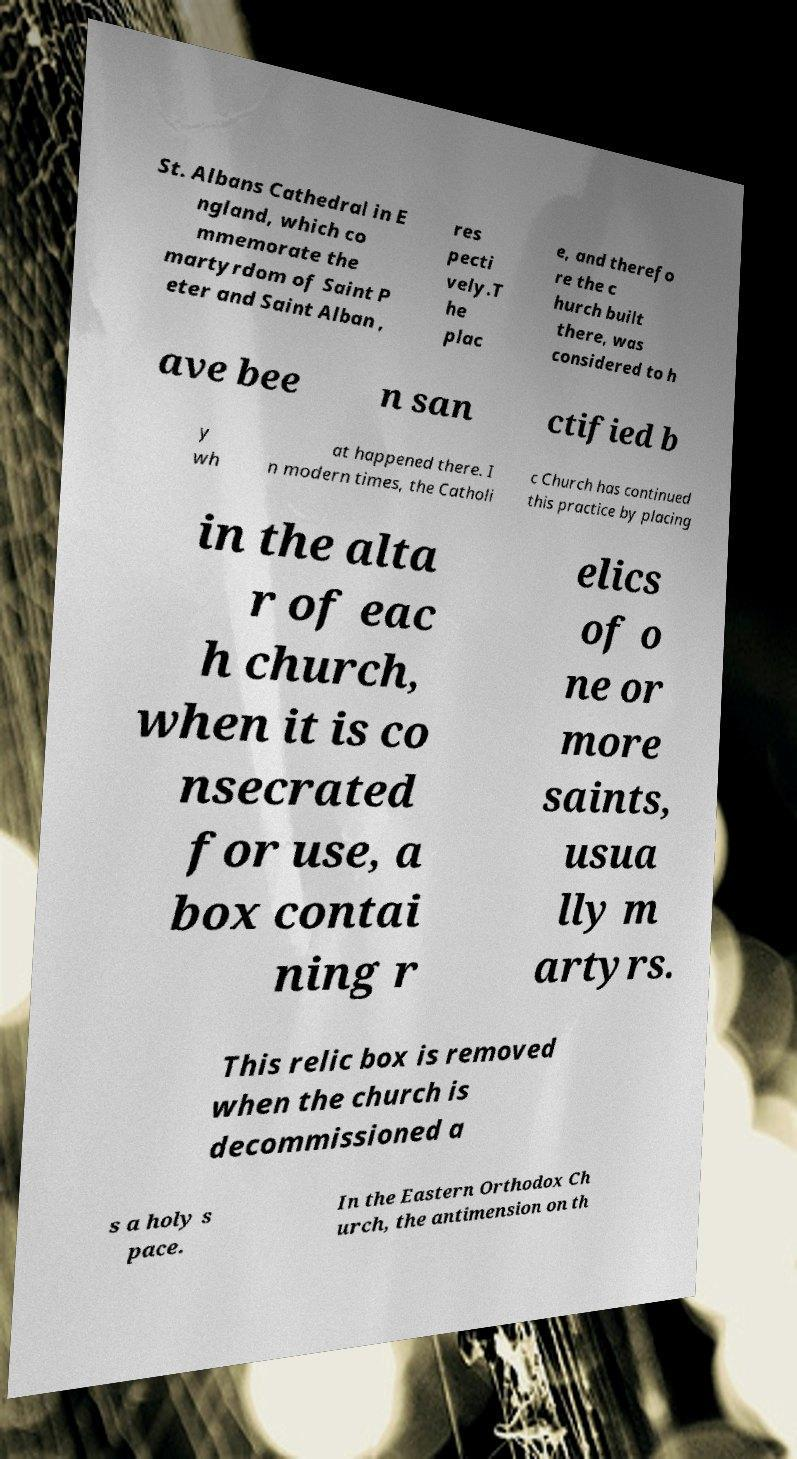Can you accurately transcribe the text from the provided image for me? St. Albans Cathedral in E ngland, which co mmemorate the martyrdom of Saint P eter and Saint Alban , res pecti vely.T he plac e, and therefo re the c hurch built there, was considered to h ave bee n san ctified b y wh at happened there. I n modern times, the Catholi c Church has continued this practice by placing in the alta r of eac h church, when it is co nsecrated for use, a box contai ning r elics of o ne or more saints, usua lly m artyrs. This relic box is removed when the church is decommissioned a s a holy s pace. In the Eastern Orthodox Ch urch, the antimension on th 